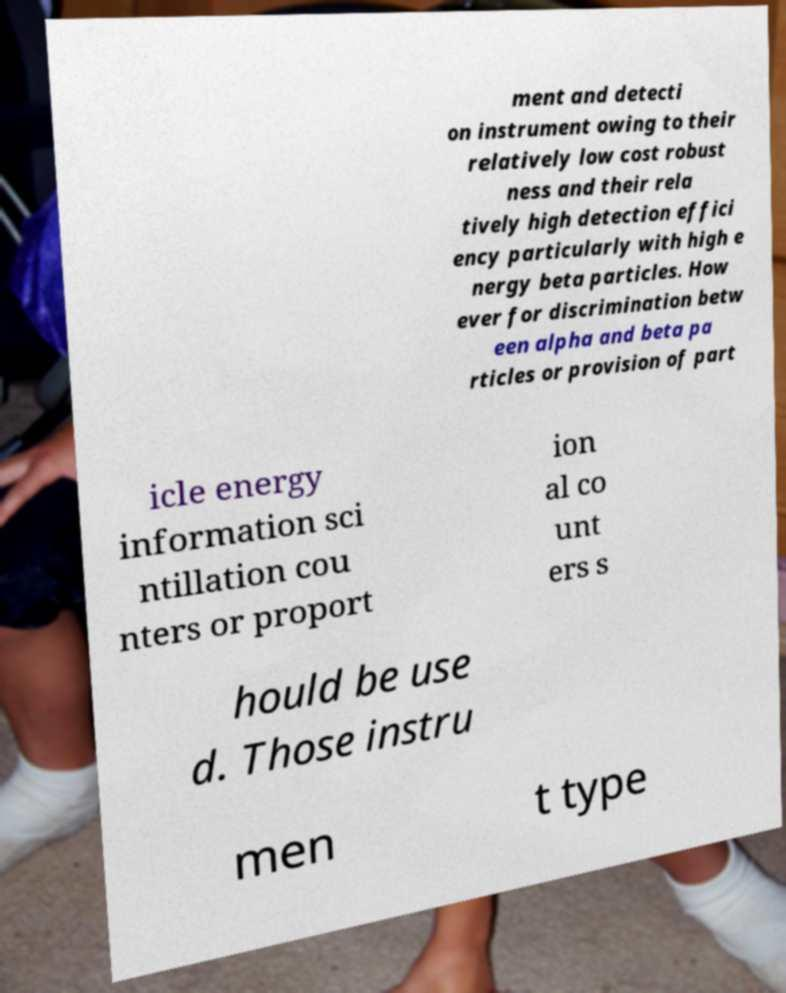Can you accurately transcribe the text from the provided image for me? ment and detecti on instrument owing to their relatively low cost robust ness and their rela tively high detection effici ency particularly with high e nergy beta particles. How ever for discrimination betw een alpha and beta pa rticles or provision of part icle energy information sci ntillation cou nters or proport ion al co unt ers s hould be use d. Those instru men t type 